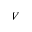<formula> <loc_0><loc_0><loc_500><loc_500>V</formula> 